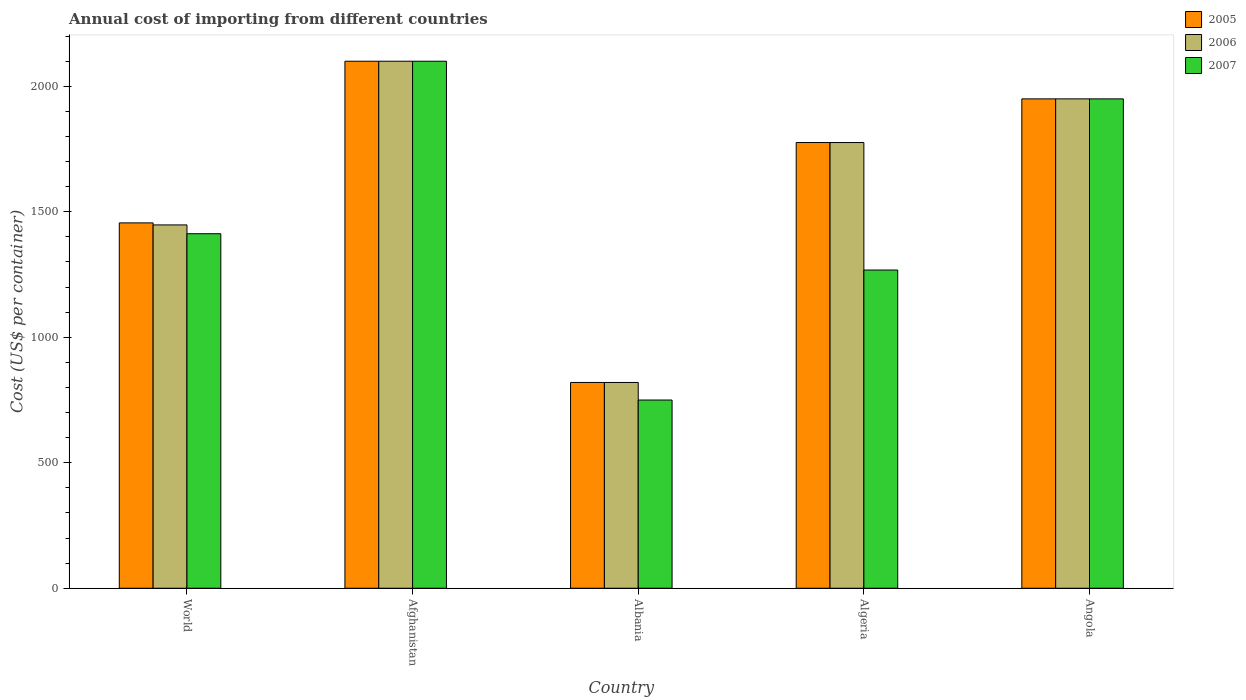How many different coloured bars are there?
Provide a short and direct response. 3. Are the number of bars per tick equal to the number of legend labels?
Offer a terse response. Yes. How many bars are there on the 2nd tick from the left?
Your answer should be compact. 3. How many bars are there on the 1st tick from the right?
Give a very brief answer. 3. What is the label of the 3rd group of bars from the left?
Provide a short and direct response. Albania. What is the total annual cost of importing in 2005 in Angola?
Your answer should be compact. 1950. Across all countries, what is the maximum total annual cost of importing in 2007?
Provide a short and direct response. 2100. Across all countries, what is the minimum total annual cost of importing in 2005?
Ensure brevity in your answer.  820. In which country was the total annual cost of importing in 2005 maximum?
Offer a terse response. Afghanistan. In which country was the total annual cost of importing in 2006 minimum?
Your response must be concise. Albania. What is the total total annual cost of importing in 2007 in the graph?
Your response must be concise. 7480.62. What is the difference between the total annual cost of importing in 2006 in Afghanistan and that in Angola?
Make the answer very short. 150. What is the difference between the total annual cost of importing in 2007 in World and the total annual cost of importing in 2005 in Afghanistan?
Provide a short and direct response. -687.38. What is the average total annual cost of importing in 2007 per country?
Offer a terse response. 1496.12. What is the difference between the total annual cost of importing of/in 2006 and total annual cost of importing of/in 2005 in Angola?
Ensure brevity in your answer.  0. In how many countries, is the total annual cost of importing in 2007 greater than 2000 US$?
Your answer should be compact. 1. What is the ratio of the total annual cost of importing in 2006 in Albania to that in World?
Your answer should be compact. 0.57. Is the total annual cost of importing in 2006 in Albania less than that in Algeria?
Ensure brevity in your answer.  Yes. Is the difference between the total annual cost of importing in 2006 in Albania and Angola greater than the difference between the total annual cost of importing in 2005 in Albania and Angola?
Give a very brief answer. No. What is the difference between the highest and the second highest total annual cost of importing in 2006?
Give a very brief answer. -324. What is the difference between the highest and the lowest total annual cost of importing in 2007?
Your answer should be very brief. 1350. What does the 1st bar from the right in World represents?
Keep it short and to the point. 2007. Is it the case that in every country, the sum of the total annual cost of importing in 2007 and total annual cost of importing in 2006 is greater than the total annual cost of importing in 2005?
Keep it short and to the point. Yes. Are the values on the major ticks of Y-axis written in scientific E-notation?
Keep it short and to the point. No. Does the graph contain any zero values?
Provide a short and direct response. No. Does the graph contain grids?
Your answer should be compact. No. Where does the legend appear in the graph?
Provide a succinct answer. Top right. How many legend labels are there?
Make the answer very short. 3. How are the legend labels stacked?
Provide a short and direct response. Vertical. What is the title of the graph?
Give a very brief answer. Annual cost of importing from different countries. Does "1990" appear as one of the legend labels in the graph?
Give a very brief answer. No. What is the label or title of the X-axis?
Offer a terse response. Country. What is the label or title of the Y-axis?
Your answer should be compact. Cost (US$ per container). What is the Cost (US$ per container) of 2005 in World?
Offer a terse response. 1455.85. What is the Cost (US$ per container) in 2006 in World?
Your response must be concise. 1447.74. What is the Cost (US$ per container) of 2007 in World?
Offer a terse response. 1412.62. What is the Cost (US$ per container) of 2005 in Afghanistan?
Give a very brief answer. 2100. What is the Cost (US$ per container) of 2006 in Afghanistan?
Make the answer very short. 2100. What is the Cost (US$ per container) of 2007 in Afghanistan?
Your response must be concise. 2100. What is the Cost (US$ per container) of 2005 in Albania?
Your answer should be very brief. 820. What is the Cost (US$ per container) of 2006 in Albania?
Your answer should be compact. 820. What is the Cost (US$ per container) of 2007 in Albania?
Offer a terse response. 750. What is the Cost (US$ per container) of 2005 in Algeria?
Provide a succinct answer. 1776. What is the Cost (US$ per container) of 2006 in Algeria?
Give a very brief answer. 1776. What is the Cost (US$ per container) of 2007 in Algeria?
Ensure brevity in your answer.  1268. What is the Cost (US$ per container) of 2005 in Angola?
Your answer should be very brief. 1950. What is the Cost (US$ per container) of 2006 in Angola?
Offer a very short reply. 1950. What is the Cost (US$ per container) of 2007 in Angola?
Give a very brief answer. 1950. Across all countries, what is the maximum Cost (US$ per container) in 2005?
Ensure brevity in your answer.  2100. Across all countries, what is the maximum Cost (US$ per container) of 2006?
Ensure brevity in your answer.  2100. Across all countries, what is the maximum Cost (US$ per container) in 2007?
Offer a very short reply. 2100. Across all countries, what is the minimum Cost (US$ per container) of 2005?
Give a very brief answer. 820. Across all countries, what is the minimum Cost (US$ per container) of 2006?
Your answer should be compact. 820. Across all countries, what is the minimum Cost (US$ per container) in 2007?
Your answer should be compact. 750. What is the total Cost (US$ per container) of 2005 in the graph?
Offer a terse response. 8101.85. What is the total Cost (US$ per container) of 2006 in the graph?
Provide a short and direct response. 8093.74. What is the total Cost (US$ per container) in 2007 in the graph?
Provide a succinct answer. 7480.62. What is the difference between the Cost (US$ per container) in 2005 in World and that in Afghanistan?
Your answer should be compact. -644.15. What is the difference between the Cost (US$ per container) of 2006 in World and that in Afghanistan?
Offer a very short reply. -652.26. What is the difference between the Cost (US$ per container) in 2007 in World and that in Afghanistan?
Provide a short and direct response. -687.38. What is the difference between the Cost (US$ per container) of 2005 in World and that in Albania?
Provide a short and direct response. 635.85. What is the difference between the Cost (US$ per container) in 2006 in World and that in Albania?
Make the answer very short. 627.74. What is the difference between the Cost (US$ per container) in 2007 in World and that in Albania?
Make the answer very short. 662.62. What is the difference between the Cost (US$ per container) of 2005 in World and that in Algeria?
Your answer should be very brief. -320.15. What is the difference between the Cost (US$ per container) in 2006 in World and that in Algeria?
Ensure brevity in your answer.  -328.26. What is the difference between the Cost (US$ per container) of 2007 in World and that in Algeria?
Your response must be concise. 144.62. What is the difference between the Cost (US$ per container) of 2005 in World and that in Angola?
Keep it short and to the point. -494.15. What is the difference between the Cost (US$ per container) of 2006 in World and that in Angola?
Provide a short and direct response. -502.26. What is the difference between the Cost (US$ per container) in 2007 in World and that in Angola?
Ensure brevity in your answer.  -537.38. What is the difference between the Cost (US$ per container) in 2005 in Afghanistan and that in Albania?
Your response must be concise. 1280. What is the difference between the Cost (US$ per container) of 2006 in Afghanistan and that in Albania?
Provide a succinct answer. 1280. What is the difference between the Cost (US$ per container) in 2007 in Afghanistan and that in Albania?
Your answer should be very brief. 1350. What is the difference between the Cost (US$ per container) in 2005 in Afghanistan and that in Algeria?
Give a very brief answer. 324. What is the difference between the Cost (US$ per container) in 2006 in Afghanistan and that in Algeria?
Your answer should be compact. 324. What is the difference between the Cost (US$ per container) in 2007 in Afghanistan and that in Algeria?
Offer a very short reply. 832. What is the difference between the Cost (US$ per container) of 2005 in Afghanistan and that in Angola?
Offer a terse response. 150. What is the difference between the Cost (US$ per container) in 2006 in Afghanistan and that in Angola?
Your answer should be compact. 150. What is the difference between the Cost (US$ per container) of 2007 in Afghanistan and that in Angola?
Provide a succinct answer. 150. What is the difference between the Cost (US$ per container) in 2005 in Albania and that in Algeria?
Your response must be concise. -956. What is the difference between the Cost (US$ per container) in 2006 in Albania and that in Algeria?
Your response must be concise. -956. What is the difference between the Cost (US$ per container) in 2007 in Albania and that in Algeria?
Provide a succinct answer. -518. What is the difference between the Cost (US$ per container) of 2005 in Albania and that in Angola?
Keep it short and to the point. -1130. What is the difference between the Cost (US$ per container) of 2006 in Albania and that in Angola?
Ensure brevity in your answer.  -1130. What is the difference between the Cost (US$ per container) in 2007 in Albania and that in Angola?
Your answer should be compact. -1200. What is the difference between the Cost (US$ per container) in 2005 in Algeria and that in Angola?
Your response must be concise. -174. What is the difference between the Cost (US$ per container) in 2006 in Algeria and that in Angola?
Provide a short and direct response. -174. What is the difference between the Cost (US$ per container) of 2007 in Algeria and that in Angola?
Make the answer very short. -682. What is the difference between the Cost (US$ per container) of 2005 in World and the Cost (US$ per container) of 2006 in Afghanistan?
Make the answer very short. -644.15. What is the difference between the Cost (US$ per container) of 2005 in World and the Cost (US$ per container) of 2007 in Afghanistan?
Offer a very short reply. -644.15. What is the difference between the Cost (US$ per container) of 2006 in World and the Cost (US$ per container) of 2007 in Afghanistan?
Offer a very short reply. -652.26. What is the difference between the Cost (US$ per container) of 2005 in World and the Cost (US$ per container) of 2006 in Albania?
Your answer should be compact. 635.85. What is the difference between the Cost (US$ per container) in 2005 in World and the Cost (US$ per container) in 2007 in Albania?
Offer a very short reply. 705.85. What is the difference between the Cost (US$ per container) in 2006 in World and the Cost (US$ per container) in 2007 in Albania?
Provide a short and direct response. 697.74. What is the difference between the Cost (US$ per container) in 2005 in World and the Cost (US$ per container) in 2006 in Algeria?
Your response must be concise. -320.15. What is the difference between the Cost (US$ per container) in 2005 in World and the Cost (US$ per container) in 2007 in Algeria?
Give a very brief answer. 187.85. What is the difference between the Cost (US$ per container) in 2006 in World and the Cost (US$ per container) in 2007 in Algeria?
Make the answer very short. 179.74. What is the difference between the Cost (US$ per container) of 2005 in World and the Cost (US$ per container) of 2006 in Angola?
Give a very brief answer. -494.15. What is the difference between the Cost (US$ per container) of 2005 in World and the Cost (US$ per container) of 2007 in Angola?
Make the answer very short. -494.15. What is the difference between the Cost (US$ per container) of 2006 in World and the Cost (US$ per container) of 2007 in Angola?
Ensure brevity in your answer.  -502.26. What is the difference between the Cost (US$ per container) in 2005 in Afghanistan and the Cost (US$ per container) in 2006 in Albania?
Your answer should be very brief. 1280. What is the difference between the Cost (US$ per container) of 2005 in Afghanistan and the Cost (US$ per container) of 2007 in Albania?
Ensure brevity in your answer.  1350. What is the difference between the Cost (US$ per container) of 2006 in Afghanistan and the Cost (US$ per container) of 2007 in Albania?
Your response must be concise. 1350. What is the difference between the Cost (US$ per container) in 2005 in Afghanistan and the Cost (US$ per container) in 2006 in Algeria?
Your answer should be compact. 324. What is the difference between the Cost (US$ per container) in 2005 in Afghanistan and the Cost (US$ per container) in 2007 in Algeria?
Your answer should be very brief. 832. What is the difference between the Cost (US$ per container) of 2006 in Afghanistan and the Cost (US$ per container) of 2007 in Algeria?
Offer a terse response. 832. What is the difference between the Cost (US$ per container) in 2005 in Afghanistan and the Cost (US$ per container) in 2006 in Angola?
Your response must be concise. 150. What is the difference between the Cost (US$ per container) of 2005 in Afghanistan and the Cost (US$ per container) of 2007 in Angola?
Provide a succinct answer. 150. What is the difference between the Cost (US$ per container) in 2006 in Afghanistan and the Cost (US$ per container) in 2007 in Angola?
Ensure brevity in your answer.  150. What is the difference between the Cost (US$ per container) in 2005 in Albania and the Cost (US$ per container) in 2006 in Algeria?
Your answer should be compact. -956. What is the difference between the Cost (US$ per container) of 2005 in Albania and the Cost (US$ per container) of 2007 in Algeria?
Your answer should be compact. -448. What is the difference between the Cost (US$ per container) in 2006 in Albania and the Cost (US$ per container) in 2007 in Algeria?
Provide a short and direct response. -448. What is the difference between the Cost (US$ per container) in 2005 in Albania and the Cost (US$ per container) in 2006 in Angola?
Offer a very short reply. -1130. What is the difference between the Cost (US$ per container) of 2005 in Albania and the Cost (US$ per container) of 2007 in Angola?
Keep it short and to the point. -1130. What is the difference between the Cost (US$ per container) of 2006 in Albania and the Cost (US$ per container) of 2007 in Angola?
Provide a succinct answer. -1130. What is the difference between the Cost (US$ per container) in 2005 in Algeria and the Cost (US$ per container) in 2006 in Angola?
Provide a succinct answer. -174. What is the difference between the Cost (US$ per container) in 2005 in Algeria and the Cost (US$ per container) in 2007 in Angola?
Keep it short and to the point. -174. What is the difference between the Cost (US$ per container) in 2006 in Algeria and the Cost (US$ per container) in 2007 in Angola?
Offer a very short reply. -174. What is the average Cost (US$ per container) of 2005 per country?
Give a very brief answer. 1620.37. What is the average Cost (US$ per container) of 2006 per country?
Provide a succinct answer. 1618.75. What is the average Cost (US$ per container) in 2007 per country?
Keep it short and to the point. 1496.12. What is the difference between the Cost (US$ per container) in 2005 and Cost (US$ per container) in 2006 in World?
Your answer should be very brief. 8.11. What is the difference between the Cost (US$ per container) of 2005 and Cost (US$ per container) of 2007 in World?
Offer a terse response. 43.23. What is the difference between the Cost (US$ per container) of 2006 and Cost (US$ per container) of 2007 in World?
Offer a terse response. 35.12. What is the difference between the Cost (US$ per container) in 2005 and Cost (US$ per container) in 2007 in Afghanistan?
Your answer should be compact. 0. What is the difference between the Cost (US$ per container) of 2006 and Cost (US$ per container) of 2007 in Afghanistan?
Your answer should be compact. 0. What is the difference between the Cost (US$ per container) in 2005 and Cost (US$ per container) in 2006 in Albania?
Offer a very short reply. 0. What is the difference between the Cost (US$ per container) of 2005 and Cost (US$ per container) of 2007 in Albania?
Provide a short and direct response. 70. What is the difference between the Cost (US$ per container) of 2006 and Cost (US$ per container) of 2007 in Albania?
Make the answer very short. 70. What is the difference between the Cost (US$ per container) in 2005 and Cost (US$ per container) in 2006 in Algeria?
Your response must be concise. 0. What is the difference between the Cost (US$ per container) of 2005 and Cost (US$ per container) of 2007 in Algeria?
Your answer should be very brief. 508. What is the difference between the Cost (US$ per container) of 2006 and Cost (US$ per container) of 2007 in Algeria?
Keep it short and to the point. 508. What is the ratio of the Cost (US$ per container) in 2005 in World to that in Afghanistan?
Offer a terse response. 0.69. What is the ratio of the Cost (US$ per container) in 2006 in World to that in Afghanistan?
Provide a succinct answer. 0.69. What is the ratio of the Cost (US$ per container) of 2007 in World to that in Afghanistan?
Offer a very short reply. 0.67. What is the ratio of the Cost (US$ per container) of 2005 in World to that in Albania?
Keep it short and to the point. 1.78. What is the ratio of the Cost (US$ per container) of 2006 in World to that in Albania?
Your response must be concise. 1.77. What is the ratio of the Cost (US$ per container) of 2007 in World to that in Albania?
Offer a very short reply. 1.88. What is the ratio of the Cost (US$ per container) in 2005 in World to that in Algeria?
Offer a very short reply. 0.82. What is the ratio of the Cost (US$ per container) of 2006 in World to that in Algeria?
Your response must be concise. 0.82. What is the ratio of the Cost (US$ per container) of 2007 in World to that in Algeria?
Offer a terse response. 1.11. What is the ratio of the Cost (US$ per container) in 2005 in World to that in Angola?
Make the answer very short. 0.75. What is the ratio of the Cost (US$ per container) in 2006 in World to that in Angola?
Provide a succinct answer. 0.74. What is the ratio of the Cost (US$ per container) in 2007 in World to that in Angola?
Provide a short and direct response. 0.72. What is the ratio of the Cost (US$ per container) of 2005 in Afghanistan to that in Albania?
Your answer should be compact. 2.56. What is the ratio of the Cost (US$ per container) in 2006 in Afghanistan to that in Albania?
Make the answer very short. 2.56. What is the ratio of the Cost (US$ per container) of 2007 in Afghanistan to that in Albania?
Provide a succinct answer. 2.8. What is the ratio of the Cost (US$ per container) in 2005 in Afghanistan to that in Algeria?
Your answer should be compact. 1.18. What is the ratio of the Cost (US$ per container) in 2006 in Afghanistan to that in Algeria?
Provide a succinct answer. 1.18. What is the ratio of the Cost (US$ per container) of 2007 in Afghanistan to that in Algeria?
Your response must be concise. 1.66. What is the ratio of the Cost (US$ per container) in 2005 in Afghanistan to that in Angola?
Provide a short and direct response. 1.08. What is the ratio of the Cost (US$ per container) in 2006 in Afghanistan to that in Angola?
Ensure brevity in your answer.  1.08. What is the ratio of the Cost (US$ per container) in 2007 in Afghanistan to that in Angola?
Offer a terse response. 1.08. What is the ratio of the Cost (US$ per container) of 2005 in Albania to that in Algeria?
Keep it short and to the point. 0.46. What is the ratio of the Cost (US$ per container) of 2006 in Albania to that in Algeria?
Provide a short and direct response. 0.46. What is the ratio of the Cost (US$ per container) in 2007 in Albania to that in Algeria?
Your response must be concise. 0.59. What is the ratio of the Cost (US$ per container) of 2005 in Albania to that in Angola?
Give a very brief answer. 0.42. What is the ratio of the Cost (US$ per container) in 2006 in Albania to that in Angola?
Provide a short and direct response. 0.42. What is the ratio of the Cost (US$ per container) in 2007 in Albania to that in Angola?
Give a very brief answer. 0.38. What is the ratio of the Cost (US$ per container) in 2005 in Algeria to that in Angola?
Make the answer very short. 0.91. What is the ratio of the Cost (US$ per container) of 2006 in Algeria to that in Angola?
Your answer should be compact. 0.91. What is the ratio of the Cost (US$ per container) of 2007 in Algeria to that in Angola?
Give a very brief answer. 0.65. What is the difference between the highest and the second highest Cost (US$ per container) in 2005?
Offer a terse response. 150. What is the difference between the highest and the second highest Cost (US$ per container) in 2006?
Provide a short and direct response. 150. What is the difference between the highest and the second highest Cost (US$ per container) of 2007?
Provide a short and direct response. 150. What is the difference between the highest and the lowest Cost (US$ per container) in 2005?
Give a very brief answer. 1280. What is the difference between the highest and the lowest Cost (US$ per container) of 2006?
Provide a succinct answer. 1280. What is the difference between the highest and the lowest Cost (US$ per container) in 2007?
Offer a terse response. 1350. 